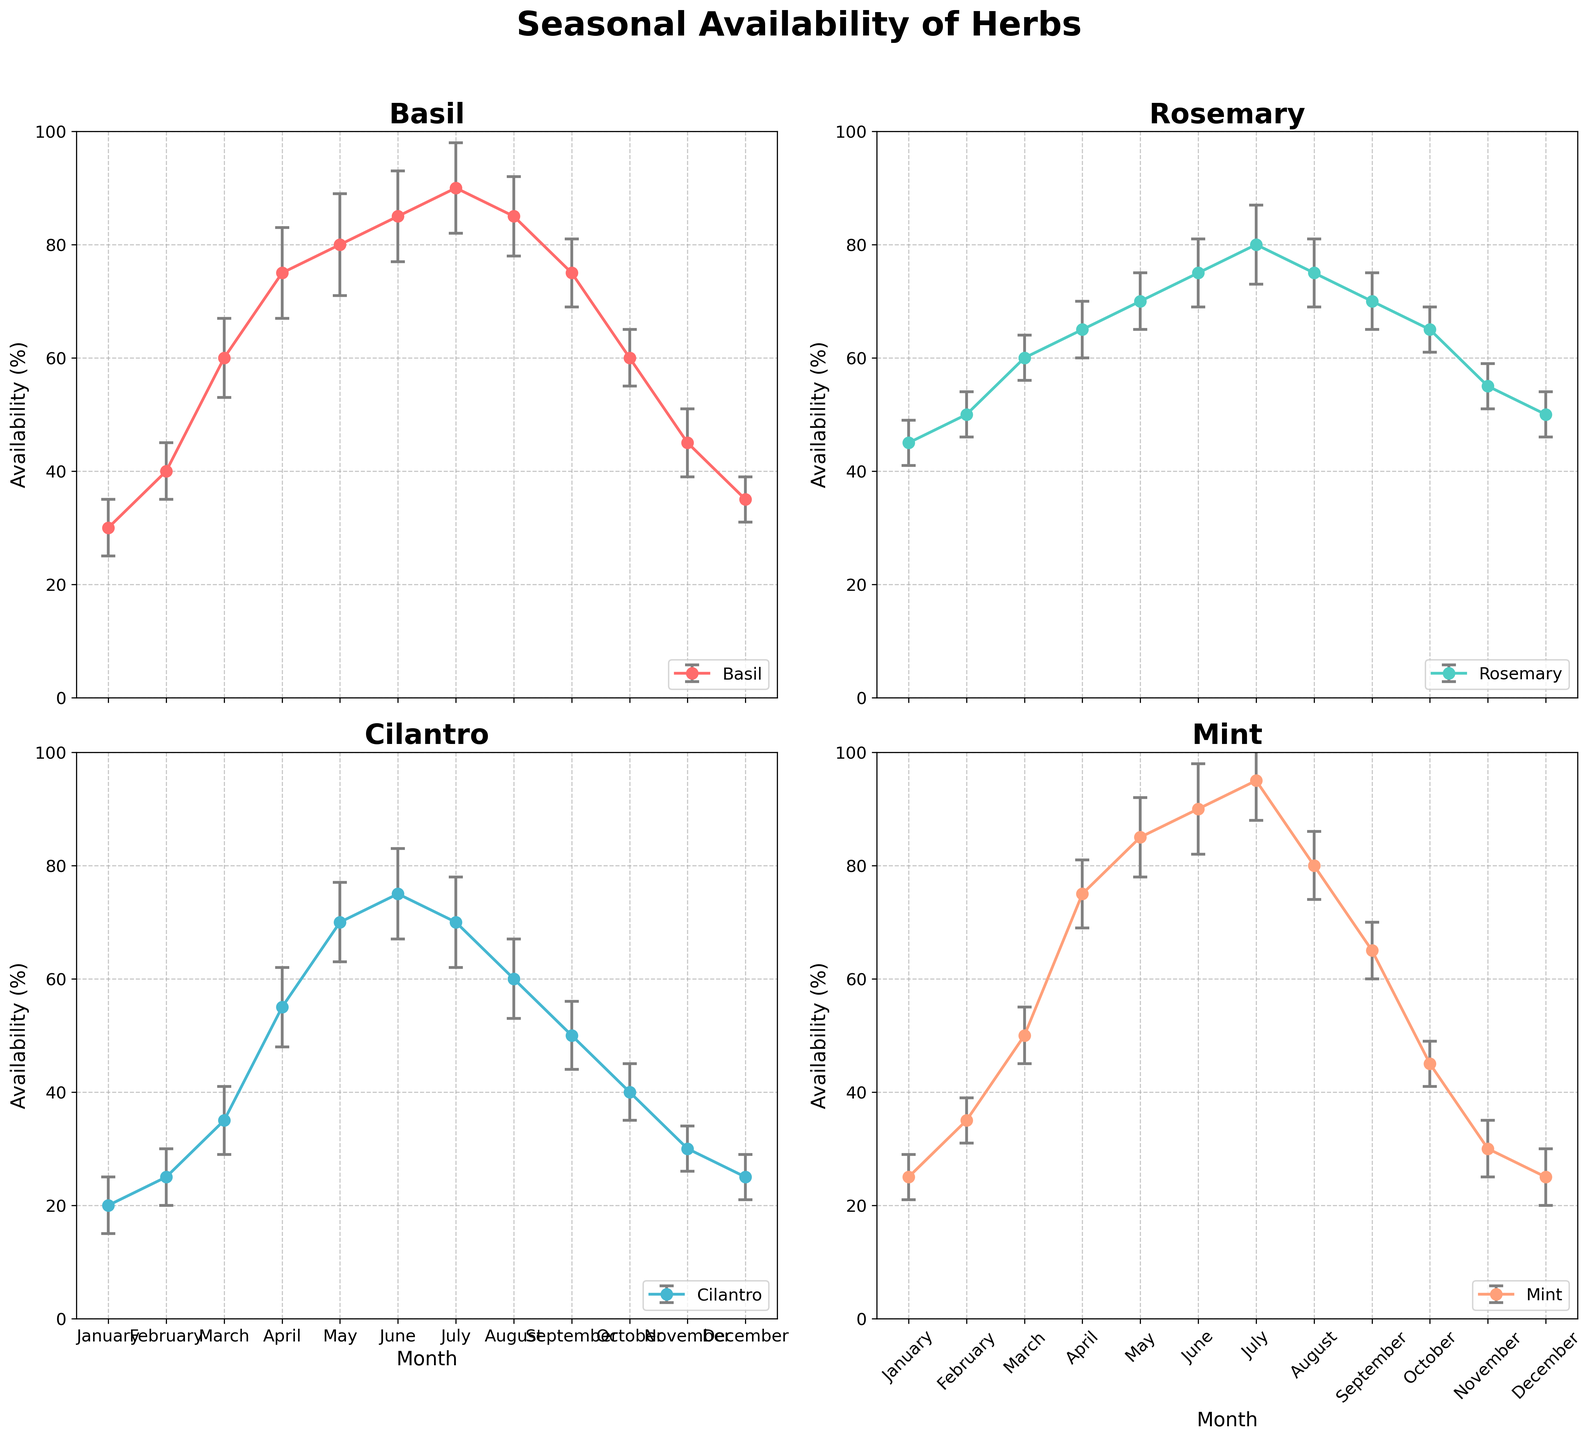What is the overall highest availability observed for any herb? The highest availability is observed for Mint in July, with an availability of 95%. To determine this, look for the tallest data points across all subplots and cross-reference them to confirm the highest value.
Answer: 95% In which months does Basil have the same availability as Rosemary? Both Basil and Rosemary have the same availability in March (60%), June (75%), and August (75%). Examine the data points in both subplots for these months to see where their values align.
Answer: March, June, August Which herb has the largest variation (difference between maximum and minimum availability)? Mint has the largest variation. The difference between its maximum (95% in July) and minimum (25% in January and December) availability is 95 - 25 = 70. Compare the max and min values for each herb to determine this.
Answer: Mint How does the availability of Cilantro in May compare with that of Rosemary in May? In May, Cilantro's availability is 70%, while Rosemary’s is also 70%. Examine the specific data points for both herbs in May to compare their values.
Answer: Equal What is the average availability of Basil from June to August? The availability values for Basil from June to August are 85%, 90%, and 85%. Calculate the average by summing these values and dividing by three: (85 + 90 + 85)/3 = 86.67.
Answer: 86.67% Which month shows the greatest decrease in availability for Mint compared to the previous month? The greatest decrease in Mint's availability occurs from July to August, where it drops from 95% to 80%. Look for the steepest downward trend in Mint's subplot and calculate the differences.
Answer: July to August In which month does Cilantro show the highest availability, and by how much does it exceed its availability in January? Cilantro shows the highest availability in June at 75%. The difference compared to its availability in January (20%) is 75 - 20 = 55. Identify the peak for Cilantro and subtract its January value.
Answer: June, 55 How does the error bar for Rosemary in December compare to the error bar for Cilantro in December? The error bar for Rosemary in December is smaller (value ±4) compared to that for Cilantro in December (value ±4). Examine the length of the error bars for both herbs in December to compare.
Answer: Smaller Which herb has the smallest fluctuation in availability throughout the year? Rosemary has the smallest fluctuation, ranging from 45% to 80%, a difference of 35. Compare the overall max and min values for each herb to determine the smallest range.
Answer: Rosemary What is the trend in availability for Mint from January to December? Mint's availability generally increases from January (25%) to a peak in July (95%) before decreasing again to December (25%). Review the data points for Mint month-by-month to observe this pattern.
Answer: Increases, then decreases 